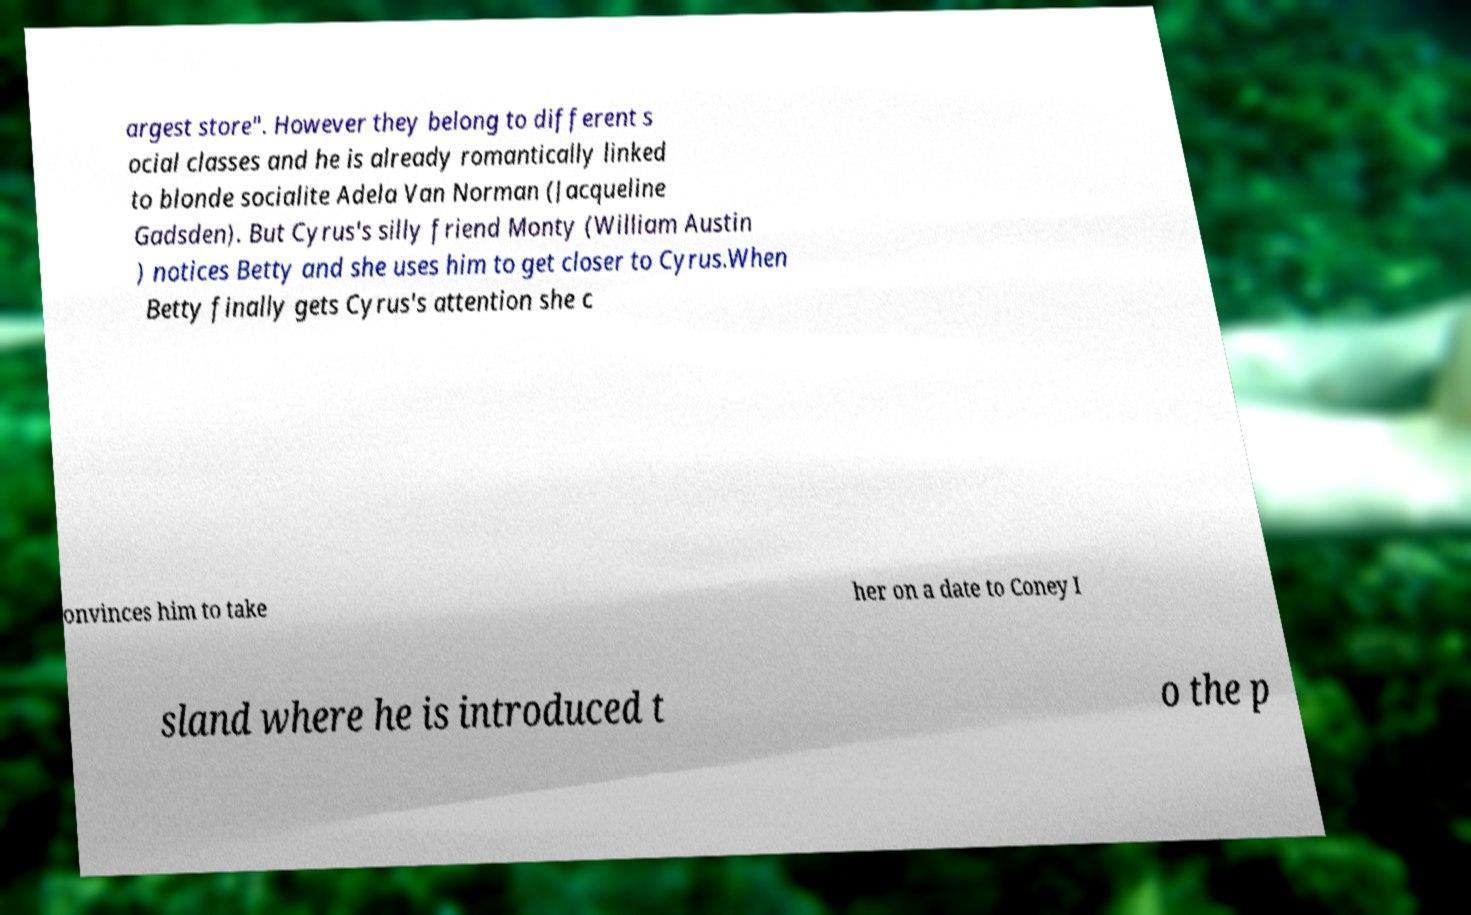Could you extract and type out the text from this image? argest store". However they belong to different s ocial classes and he is already romantically linked to blonde socialite Adela Van Norman (Jacqueline Gadsden). But Cyrus's silly friend Monty (William Austin ) notices Betty and she uses him to get closer to Cyrus.When Betty finally gets Cyrus's attention she c onvinces him to take her on a date to Coney I sland where he is introduced t o the p 